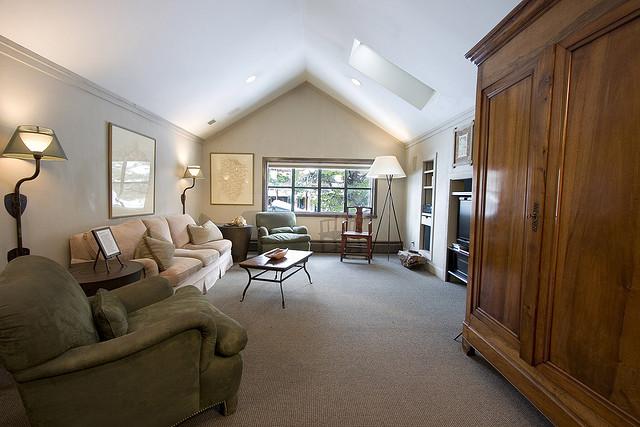What color is the couch?
Concise answer only. Tan. How many lamps are in the room?
Short answer required. 3. How many squares are on the window?
Write a very short answer. 8. 